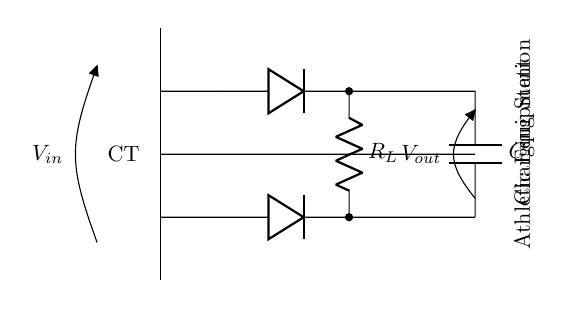What type of rectifier is shown in the circuit? The circuit diagram illustrates a center-tapped full-wave rectifier, indicated by the center-tapped transformer and the two diodes connected to the load resistor.
Answer: center-tapped full-wave rectifier How many diodes are in the circuit? There are two diodes present in the circuit, as seen in the connections from the center-tap to the load during each half cycle.
Answer: two What component smooths the output voltage? The capacitor is the component designed to smooth the output voltage by reducing fluctuations. The capacitor is placed in parallel with the load resistor.
Answer: capacitor What is the purpose of the load resistor in this circuit? The load resistor serves to dissipate the power from the rectified output voltage, allowing the circuit to deliver current to the connected athletic equipment.
Answer: dissipate power During which cycle does diode 1 conduct? Diode 1 conducts during the positive half-cycle of the alternating input voltage, allowing current to flow through the load.
Answer: positive half-cycle What is the output voltage across the load resistor? The output voltage can vary but is typically related to the peak input voltage minus the forward voltage drops across the diodes. In this representation, it is denoted as Vout.
Answer: Vout 